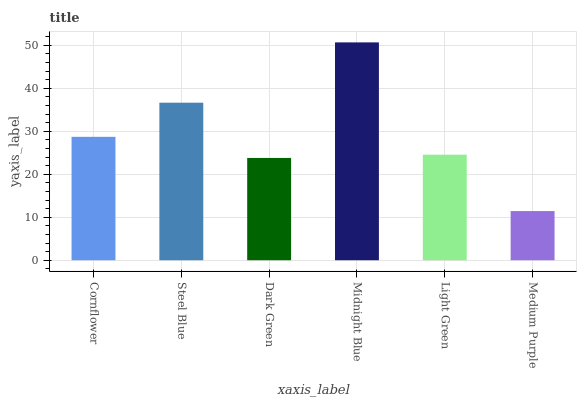Is Medium Purple the minimum?
Answer yes or no. Yes. Is Midnight Blue the maximum?
Answer yes or no. Yes. Is Steel Blue the minimum?
Answer yes or no. No. Is Steel Blue the maximum?
Answer yes or no. No. Is Steel Blue greater than Cornflower?
Answer yes or no. Yes. Is Cornflower less than Steel Blue?
Answer yes or no. Yes. Is Cornflower greater than Steel Blue?
Answer yes or no. No. Is Steel Blue less than Cornflower?
Answer yes or no. No. Is Cornflower the high median?
Answer yes or no. Yes. Is Light Green the low median?
Answer yes or no. Yes. Is Dark Green the high median?
Answer yes or no. No. Is Steel Blue the low median?
Answer yes or no. No. 